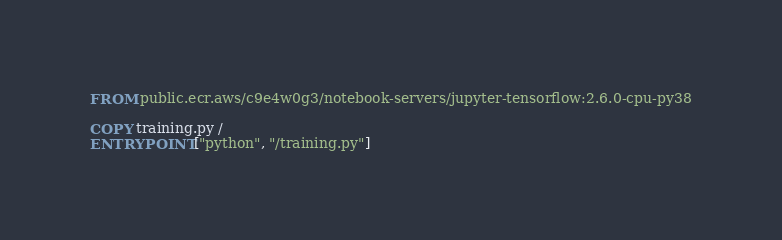<code> <loc_0><loc_0><loc_500><loc_500><_Dockerfile_>FROM public.ecr.aws/c9e4w0g3/notebook-servers/jupyter-tensorflow:2.6.0-cpu-py38

COPY training.py /
ENTRYPOINT ["python", "/training.py"]</code> 